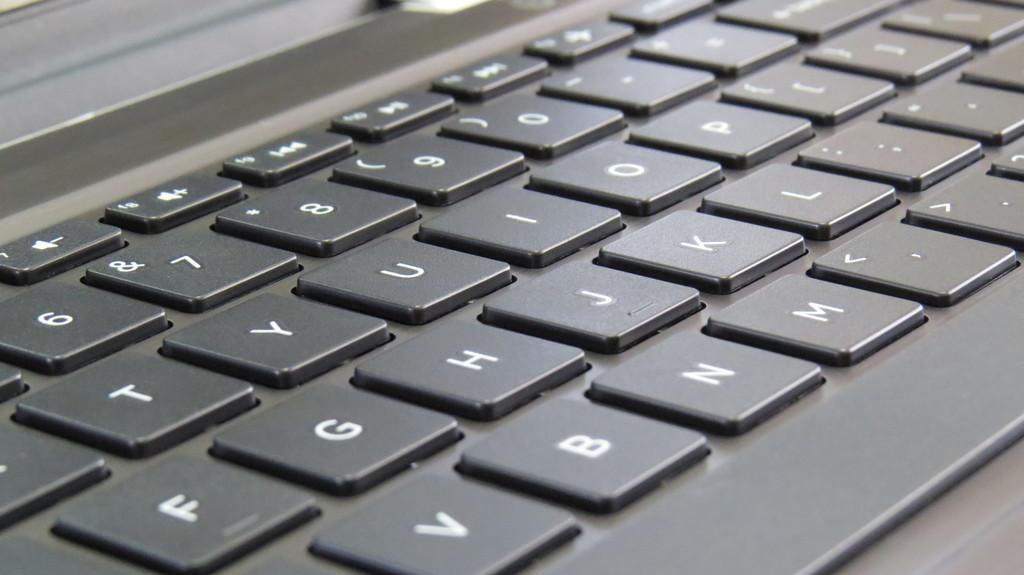What number is most to the left in this photo?
Provide a short and direct response. 6. What key is to the left of the letter b?
Provide a succinct answer. V. 